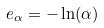Convert formula to latex. <formula><loc_0><loc_0><loc_500><loc_500>e _ { \alpha } = - \ln ( \alpha )</formula> 